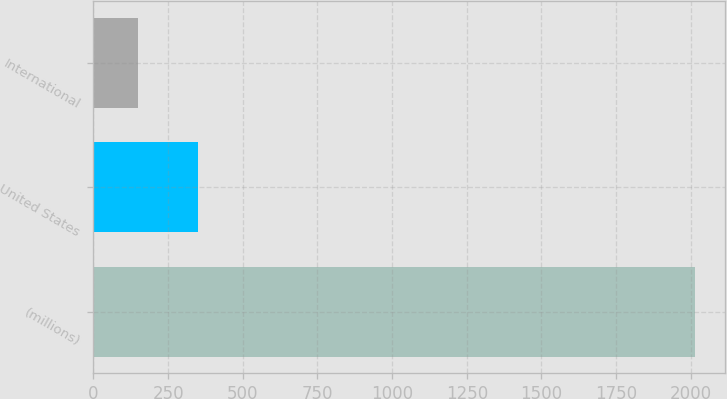<chart> <loc_0><loc_0><loc_500><loc_500><bar_chart><fcel>(millions)<fcel>United States<fcel>International<nl><fcel>2013<fcel>351.2<fcel>148.2<nl></chart> 